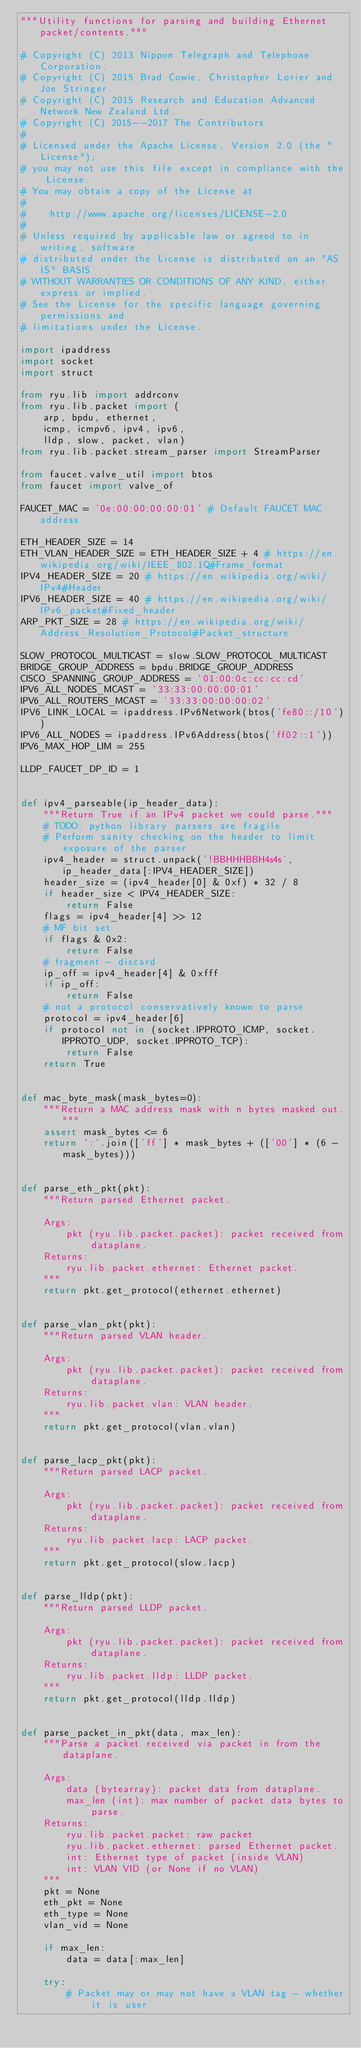Convert code to text. <code><loc_0><loc_0><loc_500><loc_500><_Python_>"""Utility functions for parsing and building Ethernet packet/contents."""

# Copyright (C) 2013 Nippon Telegraph and Telephone Corporation.
# Copyright (C) 2015 Brad Cowie, Christopher Lorier and Joe Stringer.
# Copyright (C) 2015 Research and Education Advanced Network New Zealand Ltd.
# Copyright (C) 2015--2017 The Contributors
#
# Licensed under the Apache License, Version 2.0 (the "License");
# you may not use this file except in compliance with the License.
# You may obtain a copy of the License at
#
#    http://www.apache.org/licenses/LICENSE-2.0
#
# Unless required by applicable law or agreed to in writing, software
# distributed under the License is distributed on an "AS IS" BASIS
# WITHOUT WARRANTIES OR CONDITIONS OF ANY KIND, either express or implied.
# See the License for the specific language governing permissions and
# limitations under the License.

import ipaddress
import socket
import struct

from ryu.lib import addrconv
from ryu.lib.packet import (
    arp, bpdu, ethernet,
    icmp, icmpv6, ipv4, ipv6,
    lldp, slow, packet, vlan)
from ryu.lib.packet.stream_parser import StreamParser

from faucet.valve_util import btos
from faucet import valve_of

FAUCET_MAC = '0e:00:00:00:00:01' # Default FAUCET MAC address

ETH_HEADER_SIZE = 14
ETH_VLAN_HEADER_SIZE = ETH_HEADER_SIZE + 4 # https://en.wikipedia.org/wiki/IEEE_802.1Q#Frame_format
IPV4_HEADER_SIZE = 20 # https://en.wikipedia.org/wiki/IPv4#Header
IPV6_HEADER_SIZE = 40 # https://en.wikipedia.org/wiki/IPv6_packet#Fixed_header
ARP_PKT_SIZE = 28 # https://en.wikipedia.org/wiki/Address_Resolution_Protocol#Packet_structure

SLOW_PROTOCOL_MULTICAST = slow.SLOW_PROTOCOL_MULTICAST
BRIDGE_GROUP_ADDRESS = bpdu.BRIDGE_GROUP_ADDRESS
CISCO_SPANNING_GROUP_ADDRESS = '01:00:0c:cc:cc:cd'
IPV6_ALL_NODES_MCAST = '33:33:00:00:00:01'
IPV6_ALL_ROUTERS_MCAST = '33:33:00:00:00:02'
IPV6_LINK_LOCAL = ipaddress.IPv6Network(btos('fe80::/10'))
IPV6_ALL_NODES = ipaddress.IPv6Address(btos('ff02::1'))
IPV6_MAX_HOP_LIM = 255

LLDP_FAUCET_DP_ID = 1


def ipv4_parseable(ip_header_data):
    """Return True if an IPv4 packet we could parse."""
    # TODO: python library parsers are fragile
    # Perform sanity checking on the header to limit exposure of the parser
    ipv4_header = struct.unpack('!BBHHHBBH4s4s', ip_header_data[:IPV4_HEADER_SIZE])
    header_size = (ipv4_header[0] & 0xf) * 32 / 8
    if header_size < IPV4_HEADER_SIZE:
        return False
    flags = ipv4_header[4] >> 12
    # MF bit set
    if flags & 0x2:
        return False
    # fragment - discard
    ip_off = ipv4_header[4] & 0xfff
    if ip_off:
        return False
    # not a protocol conservatively known to parse
    protocol = ipv4_header[6]
    if protocol not in (socket.IPPROTO_ICMP, socket.IPPROTO_UDP, socket.IPPROTO_TCP):
        return False
    return True


def mac_byte_mask(mask_bytes=0):
    """Return a MAC address mask with n bytes masked out."""
    assert mask_bytes <= 6
    return ':'.join(['ff'] * mask_bytes + (['00'] * (6 - mask_bytes)))


def parse_eth_pkt(pkt):
    """Return parsed Ethernet packet.

    Args:
        pkt (ryu.lib.packet.packet): packet received from dataplane.
    Returns:
        ryu.lib.packet.ethernet: Ethernet packet.
    """
    return pkt.get_protocol(ethernet.ethernet)


def parse_vlan_pkt(pkt):
    """Return parsed VLAN header.

    Args:
        pkt (ryu.lib.packet.packet): packet received from dataplane.
    Returns:
        ryu.lib.packet.vlan: VLAN header.
    """
    return pkt.get_protocol(vlan.vlan)


def parse_lacp_pkt(pkt):
    """Return parsed LACP packet.

    Args:
        pkt (ryu.lib.packet.packet): packet received from dataplane.
    Returns:
        ryu.lib.packet.lacp: LACP packet.
    """
    return pkt.get_protocol(slow.lacp)


def parse_lldp(pkt):
    """Return parsed LLDP packet.

    Args:
        pkt (ryu.lib.packet.packet): packet received from dataplane.
    Returns:
        ryu.lib.packet.lldp: LLDP packet.
    """
    return pkt.get_protocol(lldp.lldp)


def parse_packet_in_pkt(data, max_len):
    """Parse a packet received via packet in from the dataplane.

    Args:
        data (bytearray): packet data from dataplane.
        max_len (int): max number of packet data bytes to parse.
    Returns:
        ryu.lib.packet.packet: raw packet
        ryu.lib.packet.ethernet: parsed Ethernet packet.
        int: Ethernet type of packet (inside VLAN)
        int: VLAN VID (or None if no VLAN)
    """
    pkt = None
    eth_pkt = None
    eth_type = None
    vlan_vid = None

    if max_len:
        data = data[:max_len]

    try:
        # Packet may or may not have a VLAN tag - whether it is user</code> 